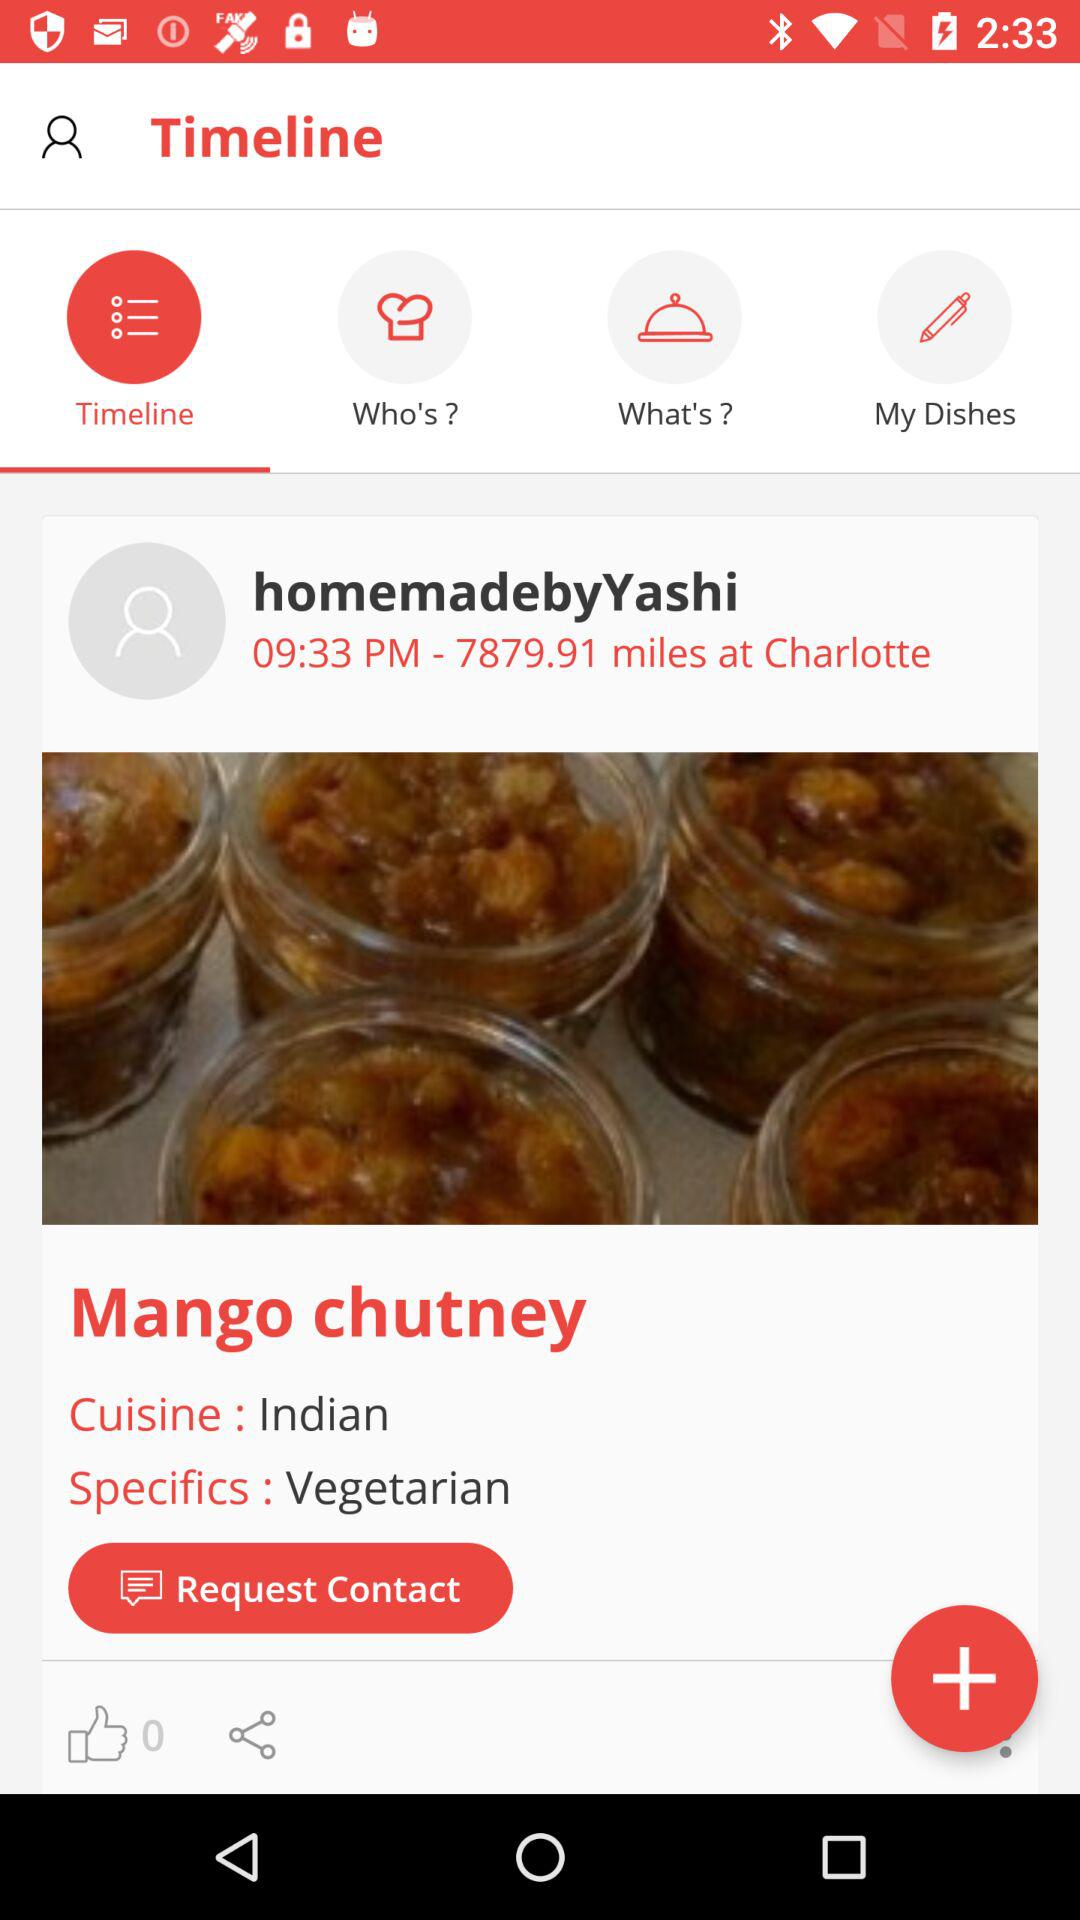What is the type of cuisine? The type of cuisine is Indian. 